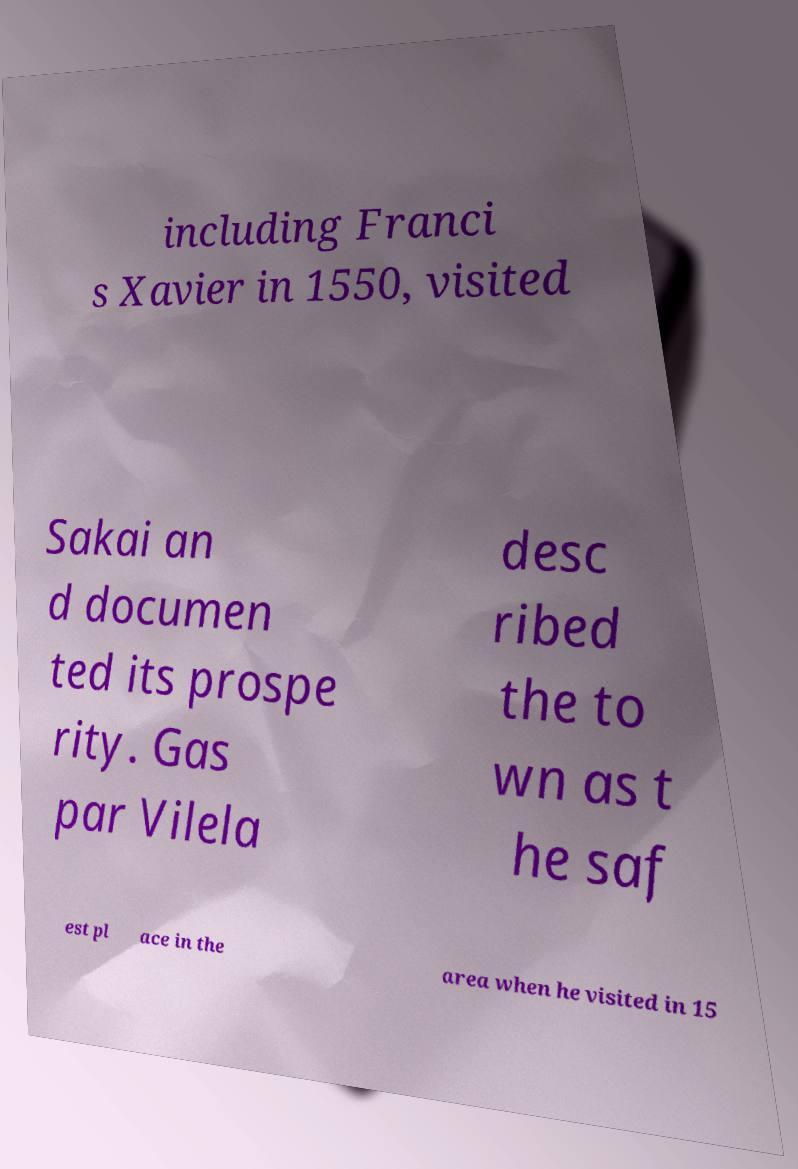What messages or text are displayed in this image? I need them in a readable, typed format. including Franci s Xavier in 1550, visited Sakai an d documen ted its prospe rity. Gas par Vilela desc ribed the to wn as t he saf est pl ace in the area when he visited in 15 